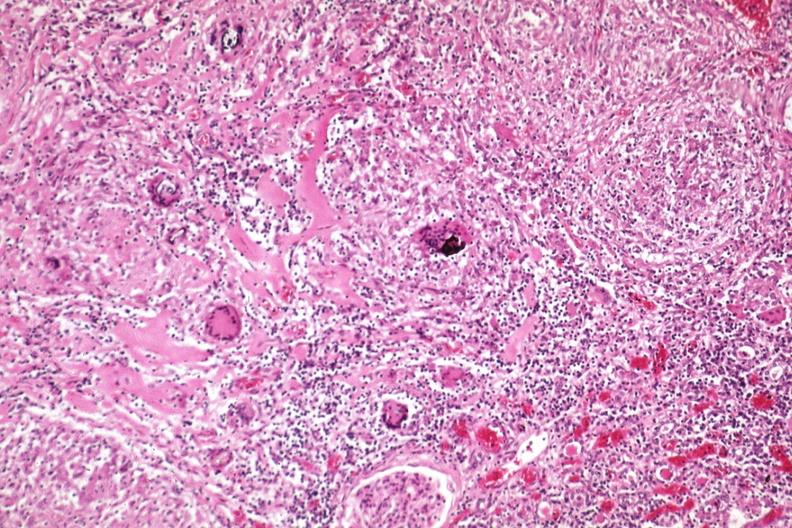does this image show giant cells and fibrosis?
Answer the question using a single word or phrase. Yes 